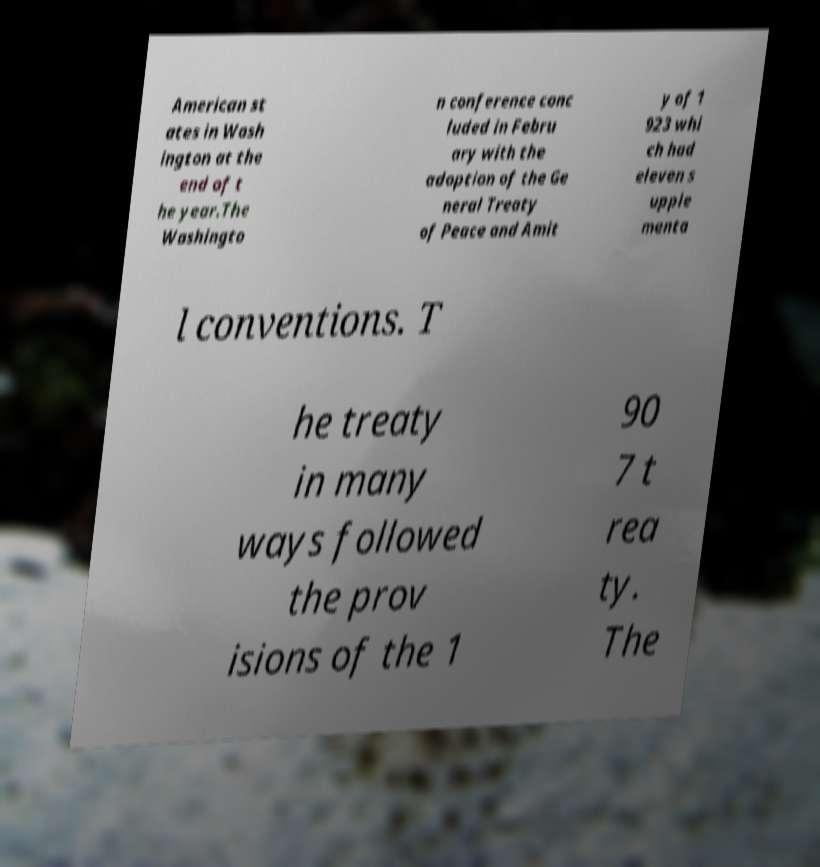Can you read and provide the text displayed in the image?This photo seems to have some interesting text. Can you extract and type it out for me? American st ates in Wash ington at the end of t he year.The Washingto n conference conc luded in Febru ary with the adoption of the Ge neral Treaty of Peace and Amit y of 1 923 whi ch had eleven s upple menta l conventions. T he treaty in many ways followed the prov isions of the 1 90 7 t rea ty. The 